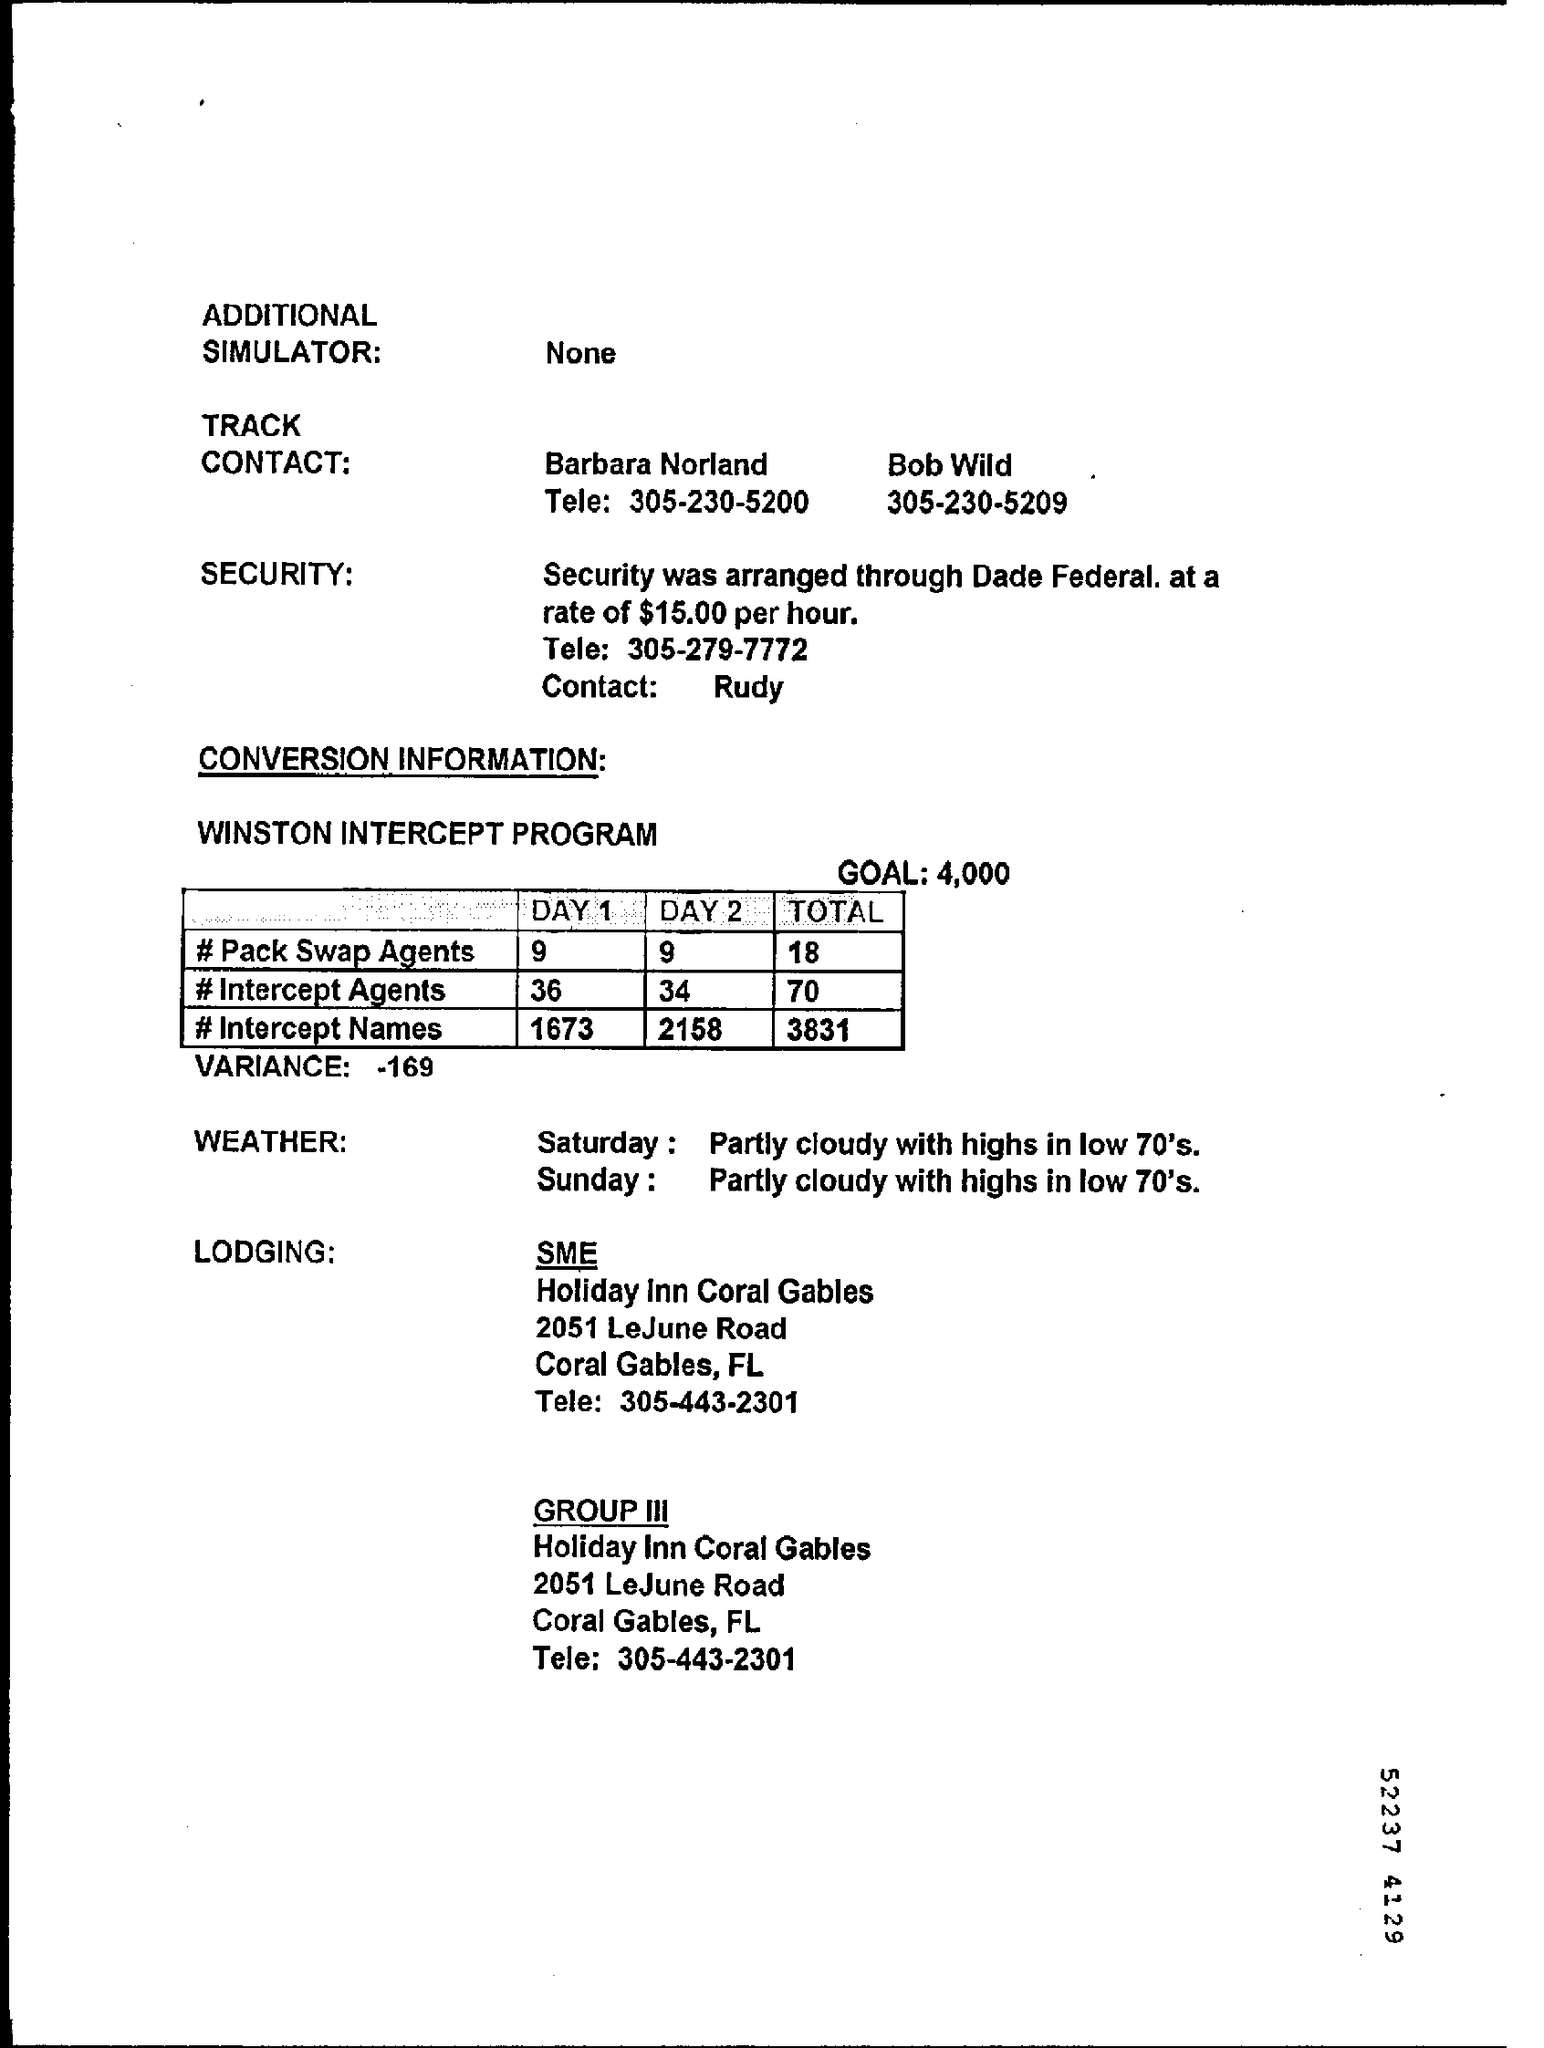Point out several critical features in this image. The hourly rate for security is $15.00. On Sunday, a partly cloudy weather was observed with highs reaching in the low 70's. The goal of the WINSTON INTERCEPT program is to achieve a target value of 4,000. The total number of intercept names is 3,831. There were 34 intercept agents during DAY2. 